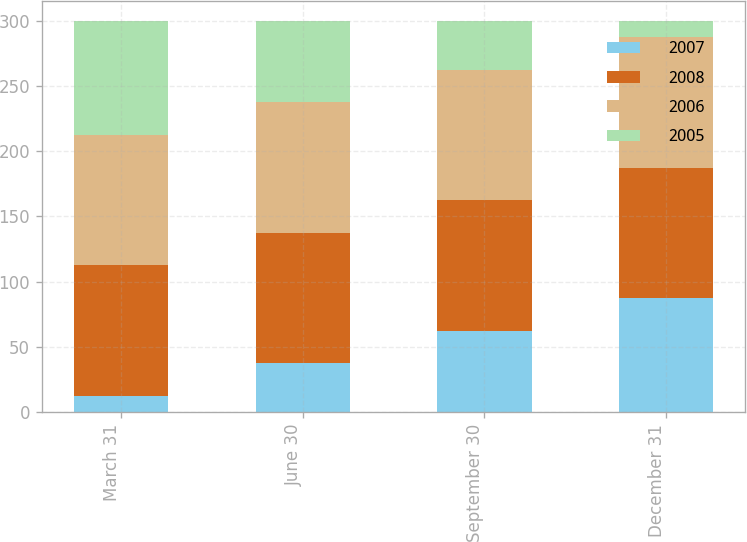Convert chart to OTSL. <chart><loc_0><loc_0><loc_500><loc_500><stacked_bar_chart><ecel><fcel>March 31<fcel>June 30<fcel>September 30<fcel>December 31<nl><fcel>2007<fcel>12.5<fcel>37.5<fcel>62.5<fcel>87.5<nl><fcel>2008<fcel>100<fcel>100<fcel>100<fcel>100<nl><fcel>2006<fcel>100<fcel>100<fcel>100<fcel>100<nl><fcel>2005<fcel>87.5<fcel>62.5<fcel>37.5<fcel>12.5<nl></chart> 